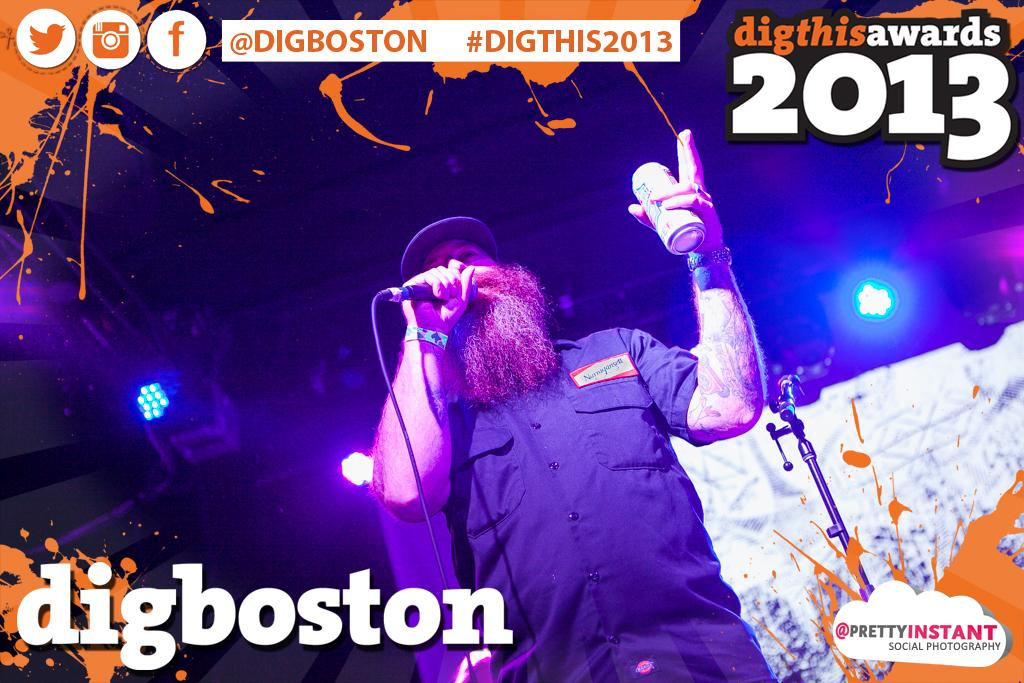<image>
Render a clear and concise summary of the photo. A photograph of a man with a microphone is labelled digboston and dated 2013. 